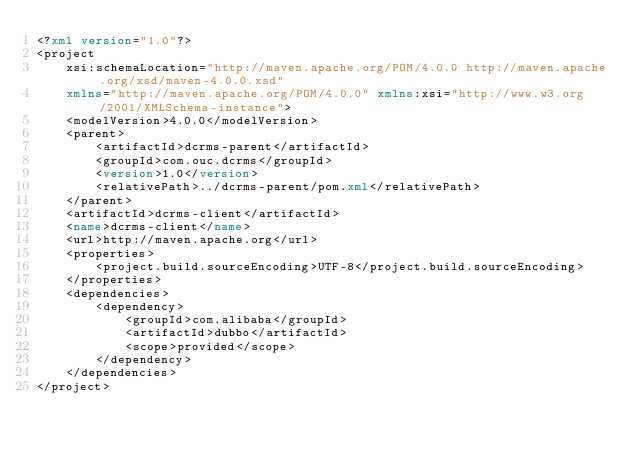Convert code to text. <code><loc_0><loc_0><loc_500><loc_500><_XML_><?xml version="1.0"?>
<project
	xsi:schemaLocation="http://maven.apache.org/POM/4.0.0 http://maven.apache.org/xsd/maven-4.0.0.xsd"
	xmlns="http://maven.apache.org/POM/4.0.0" xmlns:xsi="http://www.w3.org/2001/XMLSchema-instance">
	<modelVersion>4.0.0</modelVersion>
	<parent>
		<artifactId>dcrms-parent</artifactId>
		<groupId>com.ouc.dcrms</groupId>
		<version>1.0</version>
		<relativePath>../dcrms-parent/pom.xml</relativePath>
	</parent>
	<artifactId>dcrms-client</artifactId>
	<name>dcrms-client</name>
	<url>http://maven.apache.org</url>
	<properties>
		<project.build.sourceEncoding>UTF-8</project.build.sourceEncoding>
	</properties>
	<dependencies>
		<dependency>
			<groupId>com.alibaba</groupId>
			<artifactId>dubbo</artifactId>
			<scope>provided</scope>
		</dependency>
	</dependencies>
</project>
</code> 